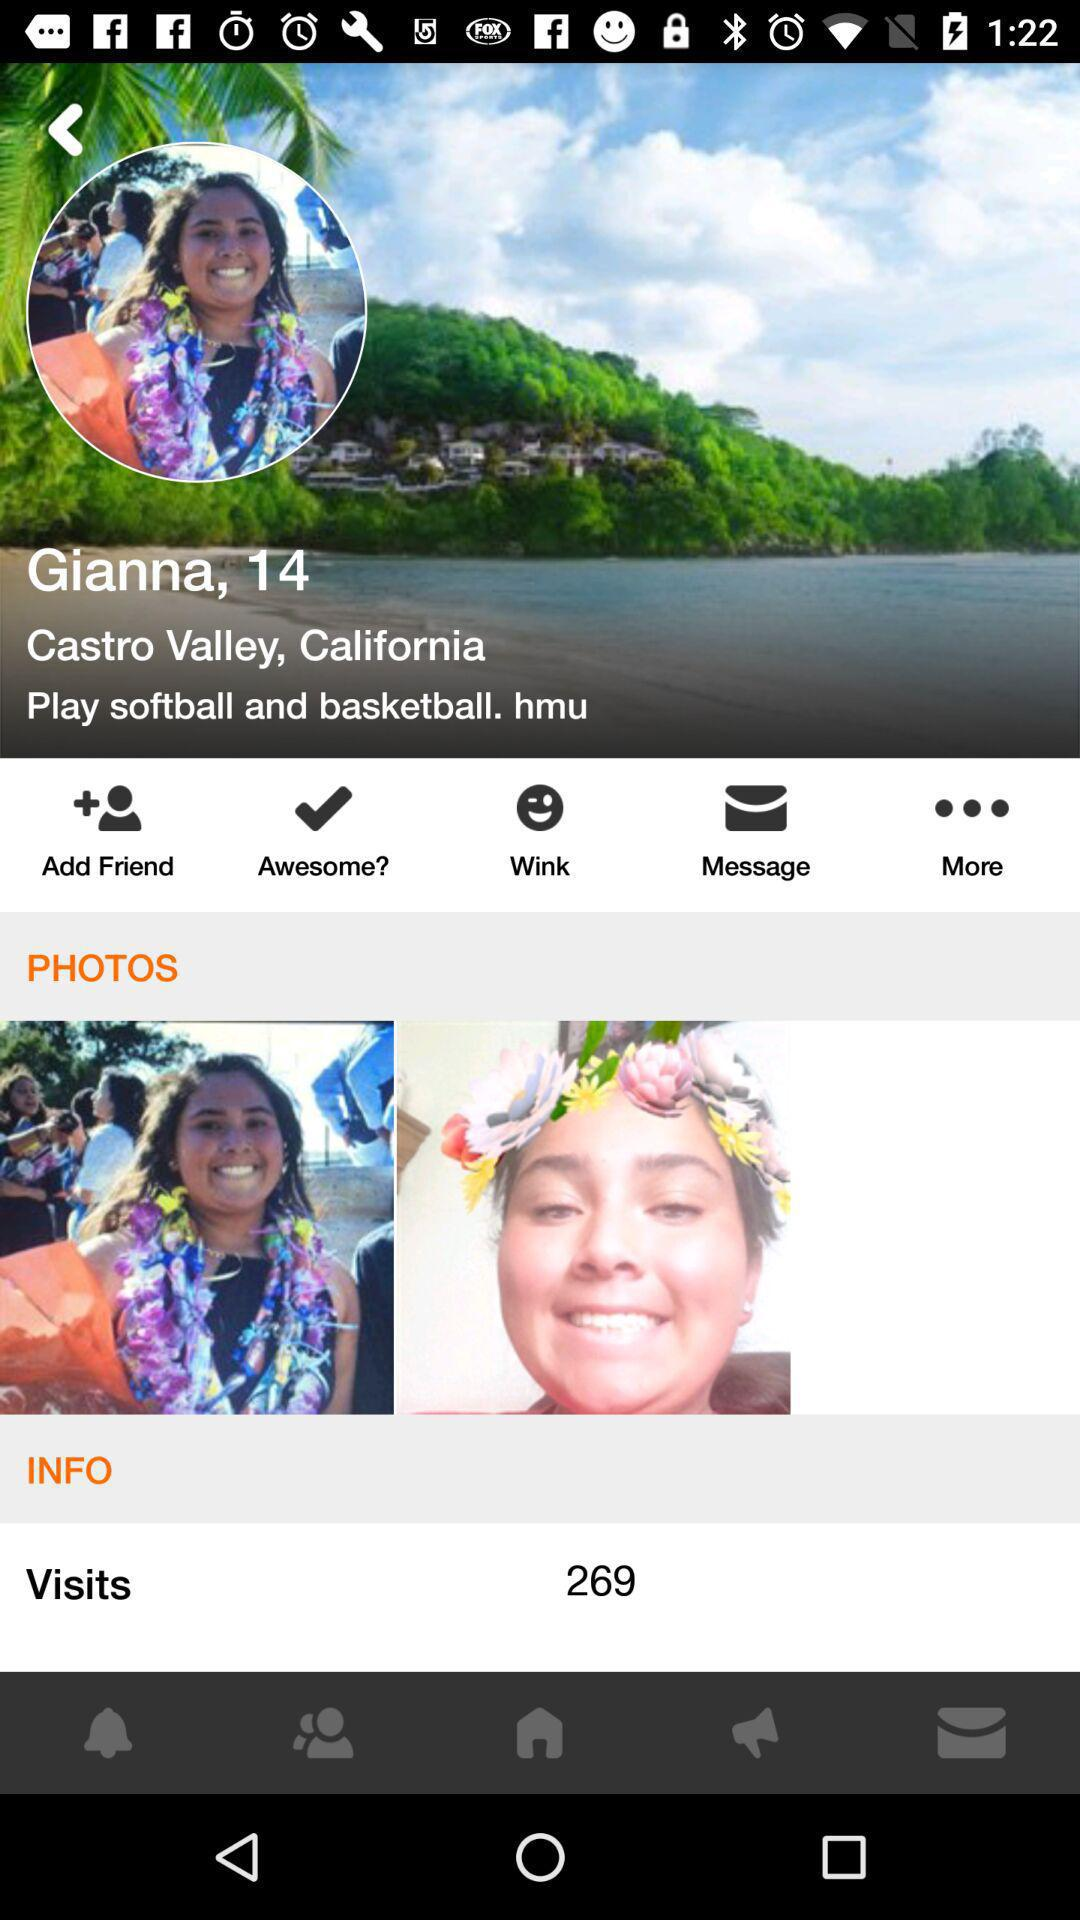What is the profile name? The profile name is Gianna. 